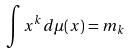Convert formula to latex. <formula><loc_0><loc_0><loc_500><loc_500>\int x ^ { k } d \mu ( x ) = m _ { k }</formula> 